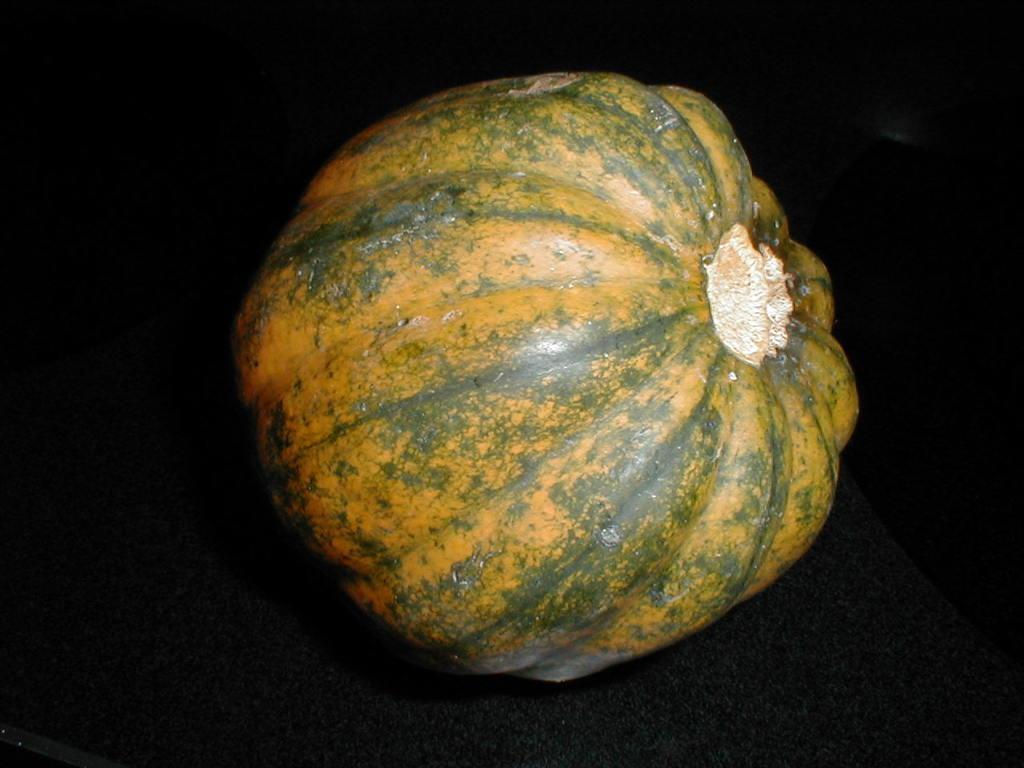In one or two sentences, can you explain what this image depicts? In the picture we can see a pumpkin which is yellow in color and some green lines which are shaded on it. 